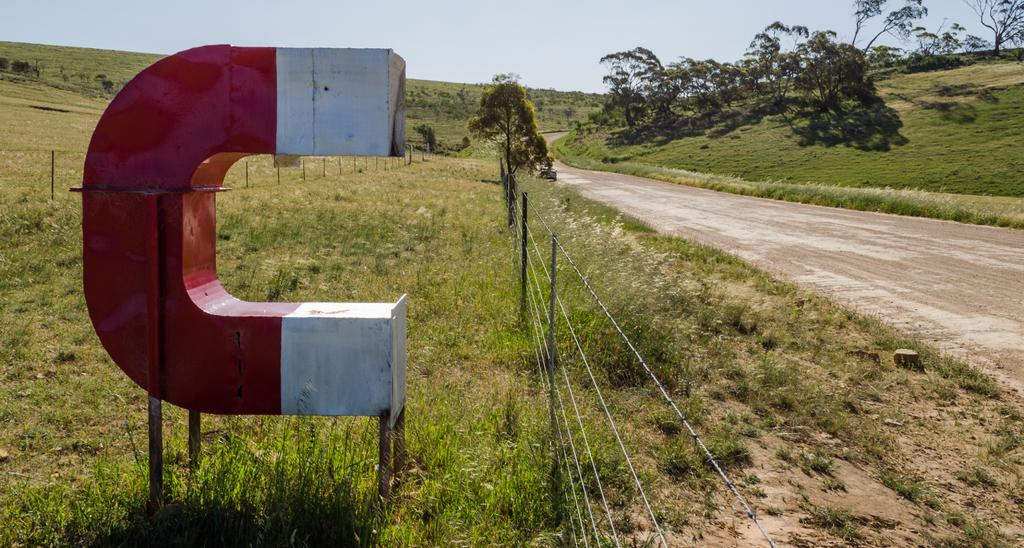What is the main feature of the image? There is a road in the image. What can be seen on the ground in the image? The ground is visible in the image. What type of vegetation is present in the image? There are trees in the image. What type of barrier is present in the image? There is fencing in the image. What type of vertical structures are present in the image? There are poles in the image. What is the color and pattern of the object in the image? There is a red and white colored object in the image. What is visible in the background of the image? The sky is visible in the background of the image. What book is the doctor reading in the image? There is no book or doctor present in the image. 